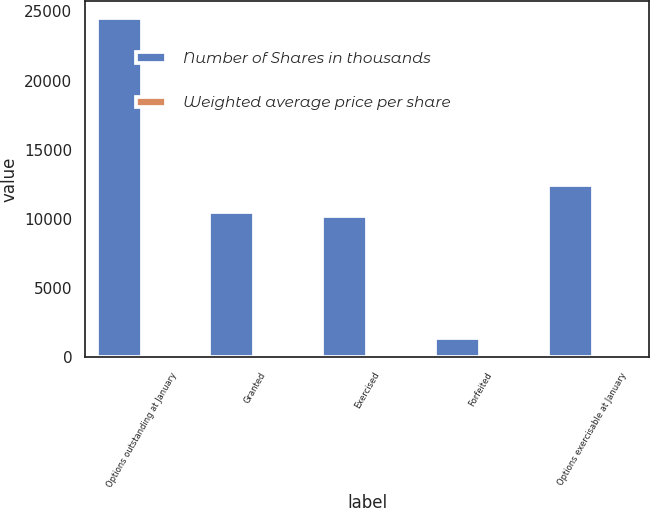Convert chart. <chart><loc_0><loc_0><loc_500><loc_500><stacked_bar_chart><ecel><fcel>Options outstanding at January<fcel>Granted<fcel>Exercised<fcel>Forfeited<fcel>Options exercisable at January<nl><fcel>Number of Shares in thousands<fcel>24506<fcel>10508<fcel>10197<fcel>1411<fcel>12446<nl><fcel>Weighted average price per share<fcel>28.75<fcel>32.25<fcel>16.12<fcel>28.21<fcel>18.73<nl></chart> 